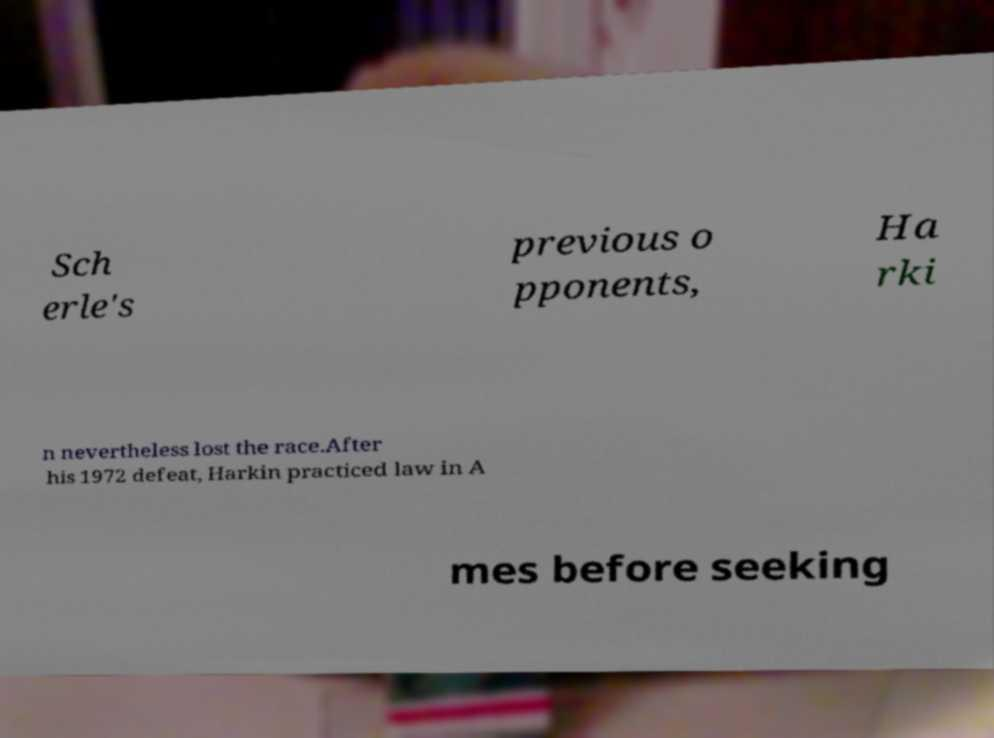Please read and relay the text visible in this image. What does it say? Sch erle's previous o pponents, Ha rki n nevertheless lost the race.After his 1972 defeat, Harkin practiced law in A mes before seeking 